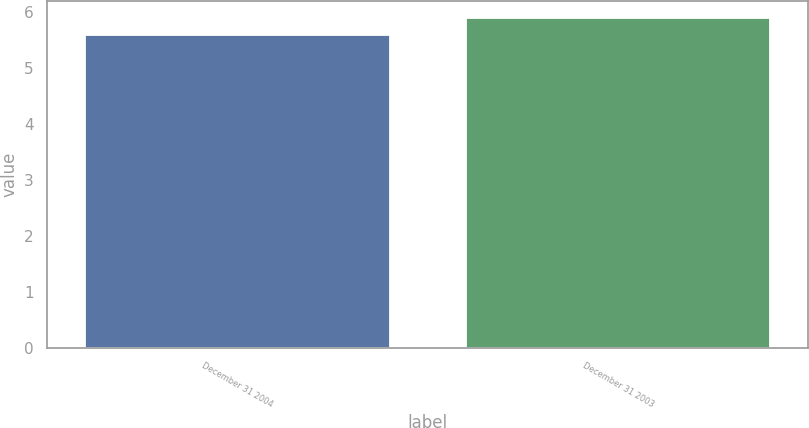Convert chart to OTSL. <chart><loc_0><loc_0><loc_500><loc_500><bar_chart><fcel>December 31 2004<fcel>December 31 2003<nl><fcel>5.6<fcel>5.9<nl></chart> 